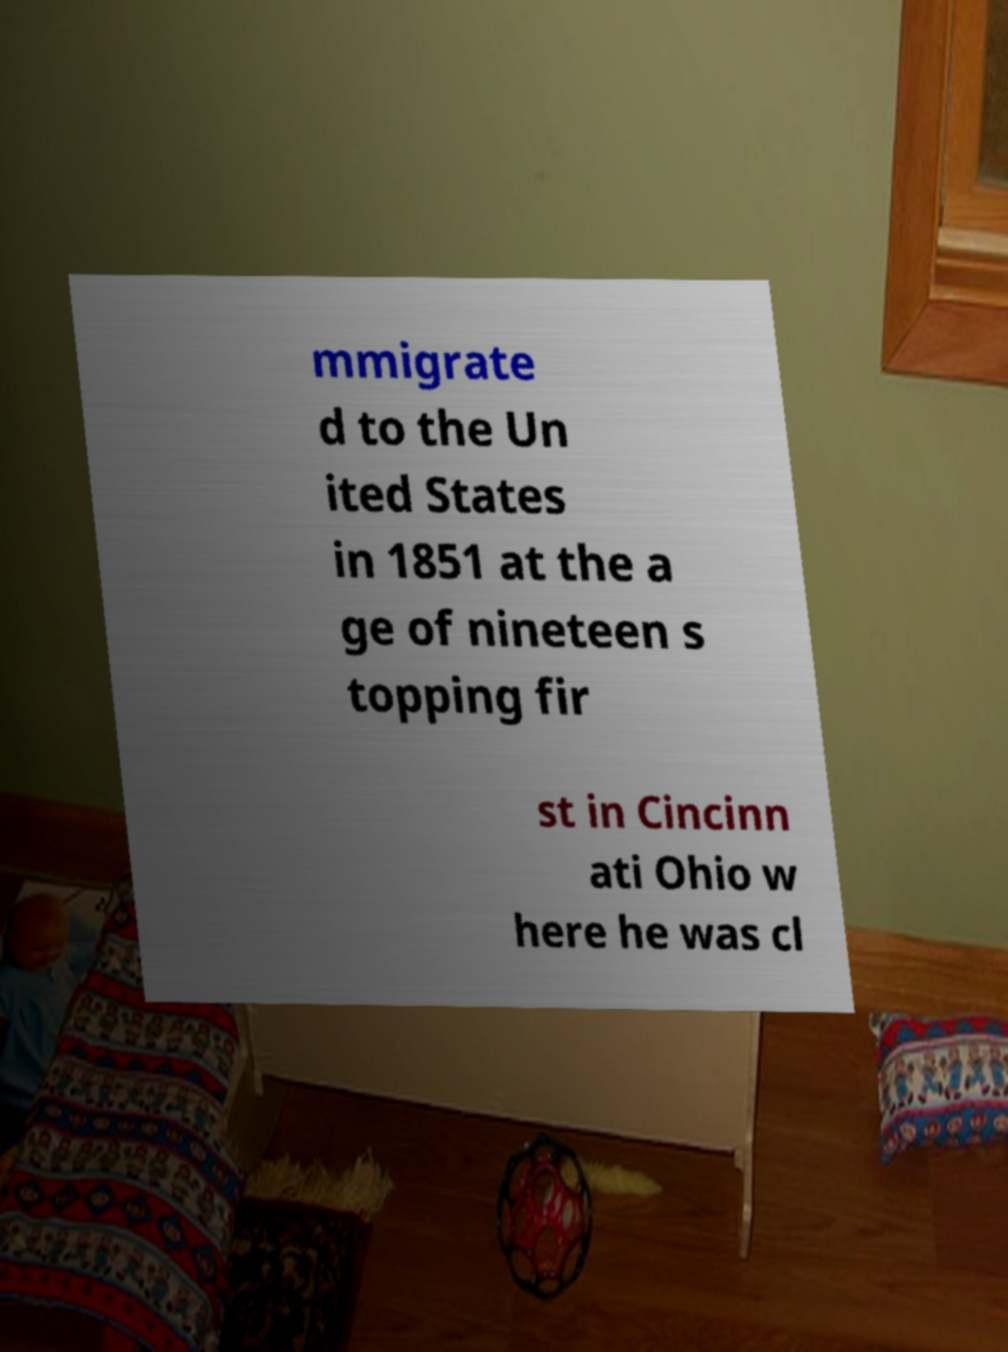Could you assist in decoding the text presented in this image and type it out clearly? mmigrate d to the Un ited States in 1851 at the a ge of nineteen s topping fir st in Cincinn ati Ohio w here he was cl 